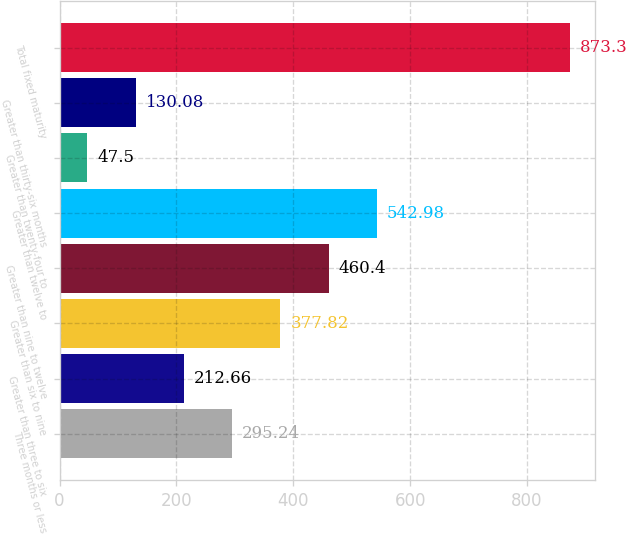Convert chart. <chart><loc_0><loc_0><loc_500><loc_500><bar_chart><fcel>Three months or less<fcel>Greater than three to six<fcel>Greater than six to nine<fcel>Greater than nine to twelve<fcel>Greater than twelve to<fcel>Greater than twenty-four to<fcel>Greater than thirty-six months<fcel>Total fixed maturity<nl><fcel>295.24<fcel>212.66<fcel>377.82<fcel>460.4<fcel>542.98<fcel>47.5<fcel>130.08<fcel>873.3<nl></chart> 